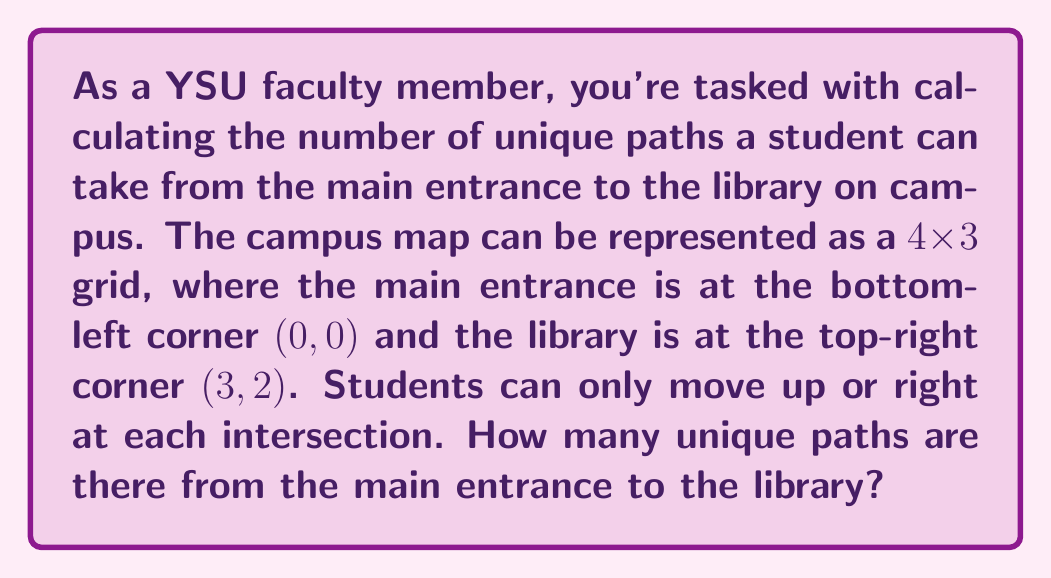Give your solution to this math problem. Let's approach this step-by-step:

1) First, let's visualize the problem. We can represent the campus as a grid:

[asy]
unitsize(1cm);
for(int i=0; i<=3; ++i)
  for(int j=0; j<=2; ++j)
    dot((i,j));
for(int i=0; i<=3; ++i)
  draw((i,0)--(i,2));
for(int j=0; j<=2; ++j)
  draw((0,j)--(3,j));
label("Start", (0,0), SW);
label("End", (3,2), NE);
[/asy]

2) To reach the library, a student must move 3 steps right and 2 steps up in any order.

3) This is a classic combination problem. We need to choose which 2 out of the 5 total moves will be upward moves (or equivalently, which 3 out of 5 will be rightward moves).

4) The number of ways to choose 2 items from 5 is given by the combination formula:

   $$\binom{5}{2} = \frac{5!}{2!(5-2)!} = \frac{5!}{2!3!}$$

5) Let's calculate this:
   $$\frac{5 * 4 * 3!}{(2 * 1) * 3!} = \frac{20}{2} = 10$$

6) Therefore, there are 10 unique paths from the main entrance to the library.

This problem demonstrates how we can use mathematical concepts to analyze and understand the layout of our campus, providing a unique perspective on the university's physical structure.
Answer: 10 unique paths 